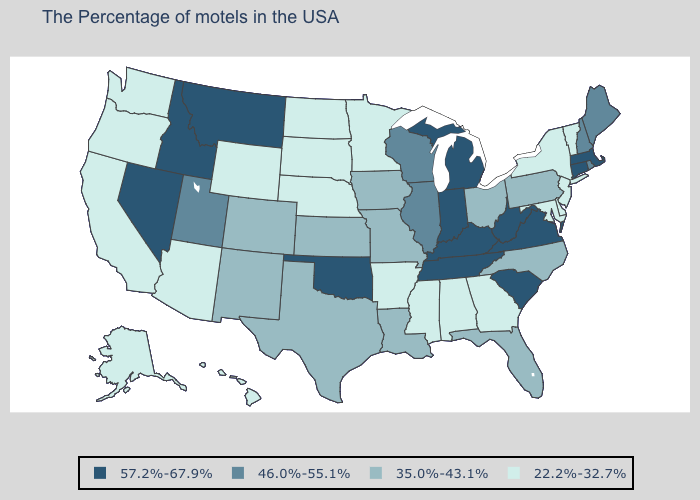Does Wisconsin have the highest value in the MidWest?
Be succinct. No. How many symbols are there in the legend?
Answer briefly. 4. Among the states that border Idaho , which have the lowest value?
Short answer required. Wyoming, Washington, Oregon. Name the states that have a value in the range 46.0%-55.1%?
Short answer required. Maine, Rhode Island, New Hampshire, Wisconsin, Illinois, Utah. Which states have the lowest value in the USA?
Write a very short answer. Vermont, New York, New Jersey, Delaware, Maryland, Georgia, Alabama, Mississippi, Arkansas, Minnesota, Nebraska, South Dakota, North Dakota, Wyoming, Arizona, California, Washington, Oregon, Alaska, Hawaii. Among the states that border Delaware , does Pennsylvania have the lowest value?
Answer briefly. No. Name the states that have a value in the range 46.0%-55.1%?
Short answer required. Maine, Rhode Island, New Hampshire, Wisconsin, Illinois, Utah. What is the value of Nevada?
Give a very brief answer. 57.2%-67.9%. Name the states that have a value in the range 46.0%-55.1%?
Give a very brief answer. Maine, Rhode Island, New Hampshire, Wisconsin, Illinois, Utah. Does Nevada have the highest value in the USA?
Be succinct. Yes. Does California have the same value as Montana?
Write a very short answer. No. What is the highest value in the South ?
Concise answer only. 57.2%-67.9%. Which states have the lowest value in the Northeast?
Write a very short answer. Vermont, New York, New Jersey. Does Texas have the highest value in the South?
Give a very brief answer. No. What is the value of Alabama?
Write a very short answer. 22.2%-32.7%. 